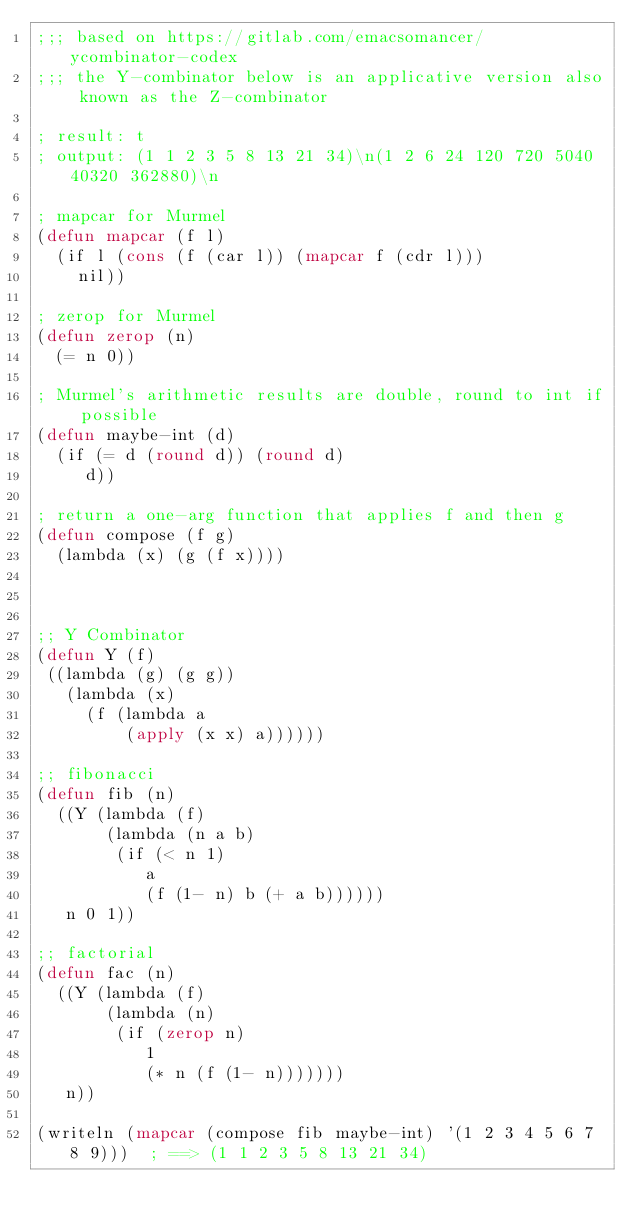<code> <loc_0><loc_0><loc_500><loc_500><_Lisp_>;;; based on https://gitlab.com/emacsomancer/ycombinator-codex
;;; the Y-combinator below is an applicative version also known as the Z-combinator

; result: t
; output: (1 1 2 3 5 8 13 21 34)\n(1 2 6 24 120 720 5040 40320 362880)\n

; mapcar for Murmel
(defun mapcar (f l)
  (if l (cons (f (car l)) (mapcar f (cdr l)))
    nil))

; zerop for Murmel
(defun zerop (n)
  (= n 0))

; Murmel's arithmetic results are double, round to int if possible
(defun maybe-int (d)
  (if (= d (round d)) (round d)
     d))

; return a one-arg function that applies f and then g
(defun compose (f g)
  (lambda (x) (g (f x))))



;; Y Combinator  
(defun Y (f)
 ((lambda (g) (g g))
   (lambda (x)
     (f (lambda a
         (apply (x x) a))))))

;; fibonacci    
(defun fib (n)
  ((Y (lambda (f)
       (lambda (n a b)
        (if (< n 1)
           a
           (f (1- n) b (+ a b))))))
   n 0 1))

;; factorial
(defun fac (n)
  ((Y (lambda (f)
       (lambda (n)
        (if (zerop n)
           1
           (* n (f (1- n)))))))
   n))

(writeln (mapcar (compose fib maybe-int) '(1 2 3 4 5 6 7 8 9)))  ; ==> (1 1 2 3 5 8 13 21 34)
</code> 